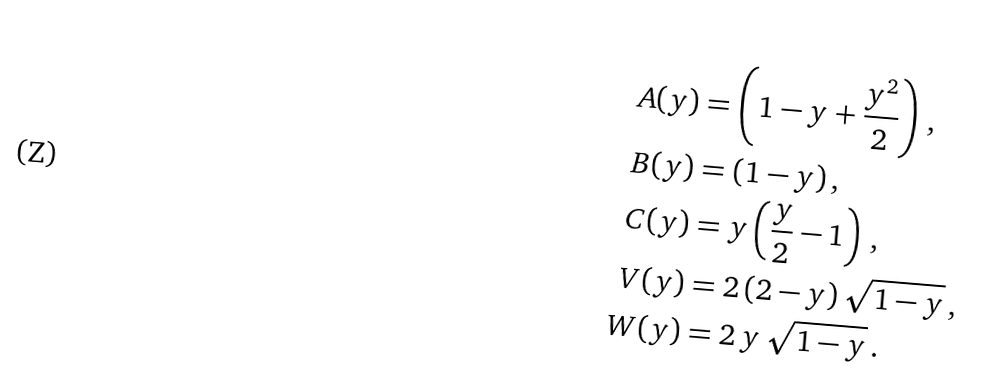Convert formula to latex. <formula><loc_0><loc_0><loc_500><loc_500>A ( y ) & = \left ( 1 - y + \frac { y ^ { 2 } } { 2 } \right ) \, , \\ B ( y ) & = ( 1 - y ) \, , \\ C ( y ) & = y \left ( \frac { y } { 2 } - 1 \right ) \, , \\ V ( y ) & = 2 \, ( 2 - y ) \, \sqrt { 1 - y } \, , \\ W ( y ) & = 2 \, y \, \sqrt { 1 - y } \, .</formula> 